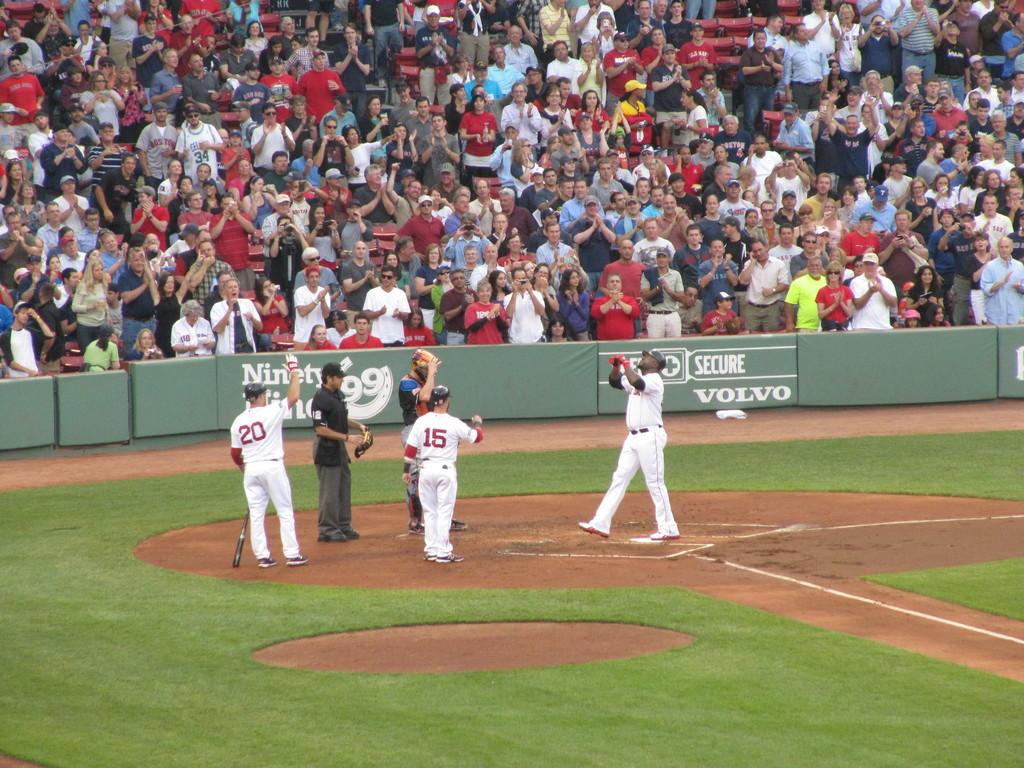What car brand is on the man standing on home plate?
Make the answer very short. Volvo. What number is the player on the left?
Offer a terse response. 20. 